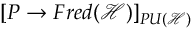<formula> <loc_0><loc_0><loc_500><loc_500>[ P \rightarrow F r e d ( { \mathcal { H } } ) ] _ { P U ( { \mathcal { H } } ) }</formula> 